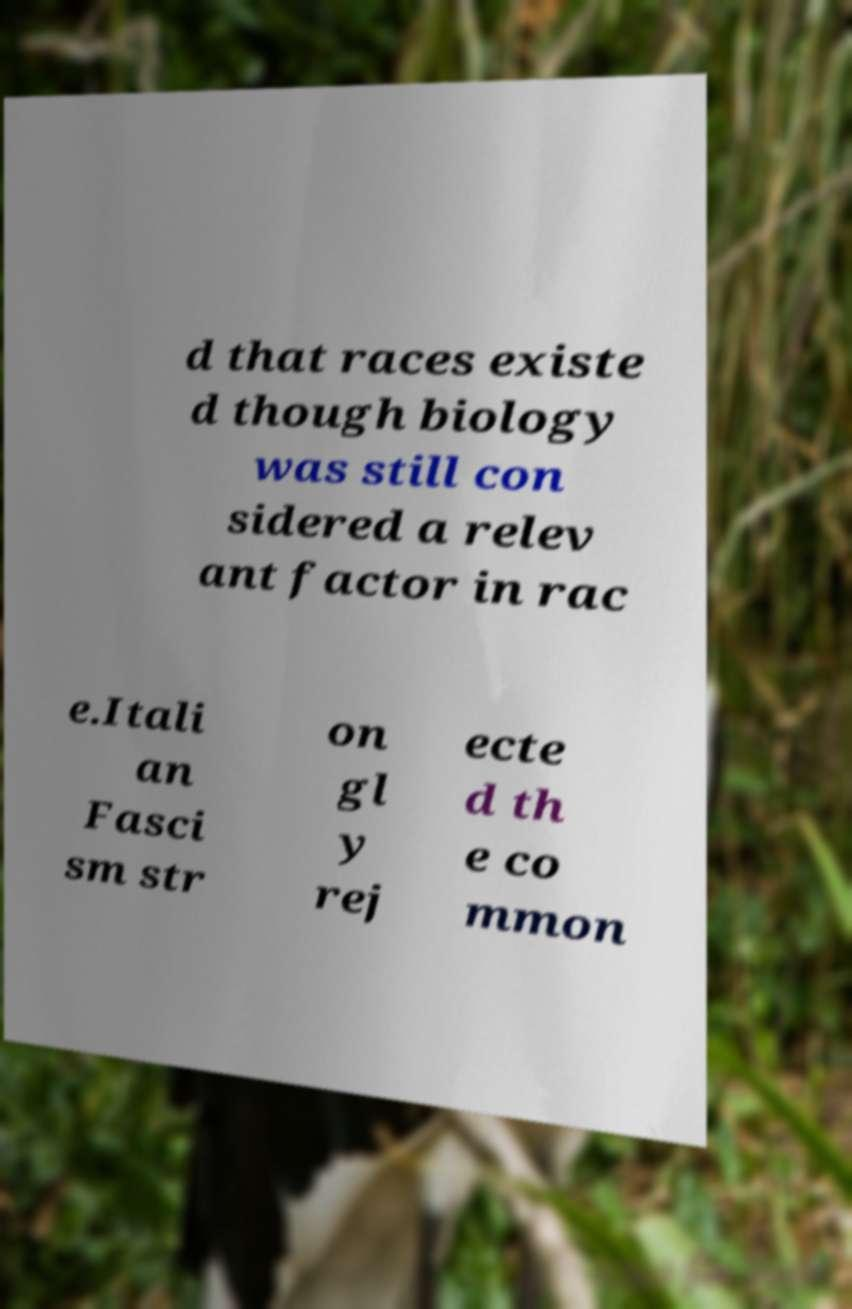Please identify and transcribe the text found in this image. d that races existe d though biology was still con sidered a relev ant factor in rac e.Itali an Fasci sm str on gl y rej ecte d th e co mmon 